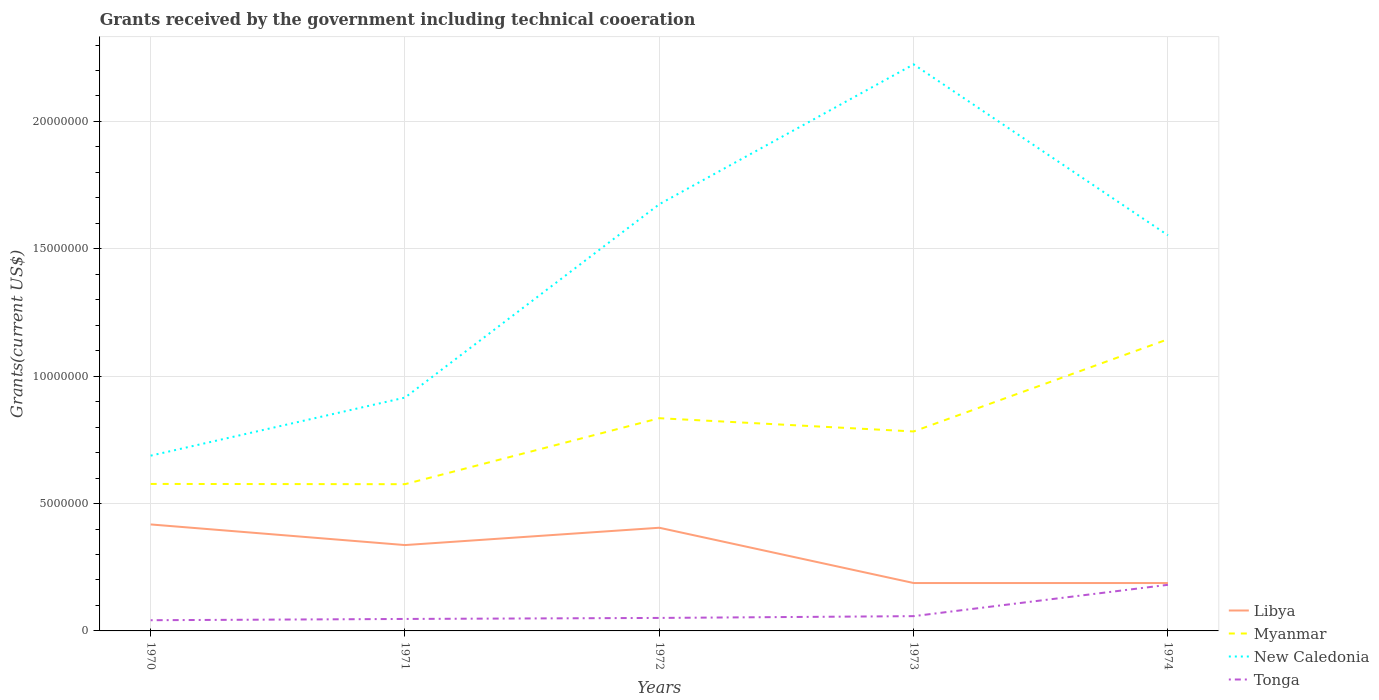How many different coloured lines are there?
Make the answer very short. 4. Across all years, what is the maximum total grants received by the government in Tonga?
Offer a very short reply. 4.20e+05. What is the total total grants received by the government in Myanmar in the graph?
Offer a terse response. -2.58e+06. What is the difference between the highest and the second highest total grants received by the government in Myanmar?
Give a very brief answer. 5.69e+06. Is the total grants received by the government in New Caledonia strictly greater than the total grants received by the government in Libya over the years?
Your answer should be very brief. No. How many lines are there?
Make the answer very short. 4. What is the difference between two consecutive major ticks on the Y-axis?
Offer a terse response. 5.00e+06. Does the graph contain any zero values?
Make the answer very short. No. Does the graph contain grids?
Ensure brevity in your answer.  Yes. Where does the legend appear in the graph?
Ensure brevity in your answer.  Bottom right. How many legend labels are there?
Provide a succinct answer. 4. How are the legend labels stacked?
Give a very brief answer. Vertical. What is the title of the graph?
Your response must be concise. Grants received by the government including technical cooeration. What is the label or title of the Y-axis?
Keep it short and to the point. Grants(current US$). What is the Grants(current US$) of Libya in 1970?
Keep it short and to the point. 4.18e+06. What is the Grants(current US$) in Myanmar in 1970?
Offer a terse response. 5.77e+06. What is the Grants(current US$) of New Caledonia in 1970?
Keep it short and to the point. 6.88e+06. What is the Grants(current US$) of Libya in 1971?
Give a very brief answer. 3.37e+06. What is the Grants(current US$) in Myanmar in 1971?
Ensure brevity in your answer.  5.76e+06. What is the Grants(current US$) in New Caledonia in 1971?
Keep it short and to the point. 9.16e+06. What is the Grants(current US$) of Libya in 1972?
Give a very brief answer. 4.05e+06. What is the Grants(current US$) of Myanmar in 1972?
Ensure brevity in your answer.  8.35e+06. What is the Grants(current US$) in New Caledonia in 1972?
Make the answer very short. 1.68e+07. What is the Grants(current US$) in Tonga in 1972?
Your answer should be compact. 5.10e+05. What is the Grants(current US$) of Libya in 1973?
Keep it short and to the point. 1.88e+06. What is the Grants(current US$) of Myanmar in 1973?
Your answer should be compact. 7.83e+06. What is the Grants(current US$) of New Caledonia in 1973?
Provide a succinct answer. 2.22e+07. What is the Grants(current US$) of Tonga in 1973?
Your answer should be very brief. 5.80e+05. What is the Grants(current US$) in Libya in 1974?
Your answer should be very brief. 1.88e+06. What is the Grants(current US$) of Myanmar in 1974?
Offer a very short reply. 1.14e+07. What is the Grants(current US$) of New Caledonia in 1974?
Keep it short and to the point. 1.55e+07. What is the Grants(current US$) of Tonga in 1974?
Ensure brevity in your answer.  1.81e+06. Across all years, what is the maximum Grants(current US$) in Libya?
Your response must be concise. 4.18e+06. Across all years, what is the maximum Grants(current US$) in Myanmar?
Keep it short and to the point. 1.14e+07. Across all years, what is the maximum Grants(current US$) in New Caledonia?
Make the answer very short. 2.22e+07. Across all years, what is the maximum Grants(current US$) in Tonga?
Your answer should be compact. 1.81e+06. Across all years, what is the minimum Grants(current US$) of Libya?
Make the answer very short. 1.88e+06. Across all years, what is the minimum Grants(current US$) in Myanmar?
Your answer should be very brief. 5.76e+06. Across all years, what is the minimum Grants(current US$) of New Caledonia?
Ensure brevity in your answer.  6.88e+06. Across all years, what is the minimum Grants(current US$) of Tonga?
Offer a terse response. 4.20e+05. What is the total Grants(current US$) in Libya in the graph?
Make the answer very short. 1.54e+07. What is the total Grants(current US$) in Myanmar in the graph?
Give a very brief answer. 3.92e+07. What is the total Grants(current US$) of New Caledonia in the graph?
Keep it short and to the point. 7.06e+07. What is the total Grants(current US$) in Tonga in the graph?
Your answer should be compact. 3.79e+06. What is the difference between the Grants(current US$) of Libya in 1970 and that in 1971?
Ensure brevity in your answer.  8.10e+05. What is the difference between the Grants(current US$) of New Caledonia in 1970 and that in 1971?
Give a very brief answer. -2.28e+06. What is the difference between the Grants(current US$) in Myanmar in 1970 and that in 1972?
Make the answer very short. -2.58e+06. What is the difference between the Grants(current US$) in New Caledonia in 1970 and that in 1972?
Your answer should be very brief. -9.87e+06. What is the difference between the Grants(current US$) of Libya in 1970 and that in 1973?
Offer a very short reply. 2.30e+06. What is the difference between the Grants(current US$) of Myanmar in 1970 and that in 1973?
Provide a short and direct response. -2.06e+06. What is the difference between the Grants(current US$) of New Caledonia in 1970 and that in 1973?
Ensure brevity in your answer.  -1.54e+07. What is the difference between the Grants(current US$) in Tonga in 1970 and that in 1973?
Keep it short and to the point. -1.60e+05. What is the difference between the Grants(current US$) in Libya in 1970 and that in 1974?
Give a very brief answer. 2.30e+06. What is the difference between the Grants(current US$) in Myanmar in 1970 and that in 1974?
Give a very brief answer. -5.68e+06. What is the difference between the Grants(current US$) in New Caledonia in 1970 and that in 1974?
Provide a succinct answer. -8.65e+06. What is the difference between the Grants(current US$) of Tonga in 1970 and that in 1974?
Make the answer very short. -1.39e+06. What is the difference between the Grants(current US$) of Libya in 1971 and that in 1972?
Provide a short and direct response. -6.80e+05. What is the difference between the Grants(current US$) of Myanmar in 1971 and that in 1972?
Your answer should be very brief. -2.59e+06. What is the difference between the Grants(current US$) in New Caledonia in 1971 and that in 1972?
Provide a short and direct response. -7.59e+06. What is the difference between the Grants(current US$) in Tonga in 1971 and that in 1972?
Keep it short and to the point. -4.00e+04. What is the difference between the Grants(current US$) of Libya in 1971 and that in 1973?
Make the answer very short. 1.49e+06. What is the difference between the Grants(current US$) of Myanmar in 1971 and that in 1973?
Your answer should be compact. -2.07e+06. What is the difference between the Grants(current US$) in New Caledonia in 1971 and that in 1973?
Make the answer very short. -1.31e+07. What is the difference between the Grants(current US$) of Tonga in 1971 and that in 1973?
Provide a succinct answer. -1.10e+05. What is the difference between the Grants(current US$) in Libya in 1971 and that in 1974?
Offer a terse response. 1.49e+06. What is the difference between the Grants(current US$) in Myanmar in 1971 and that in 1974?
Ensure brevity in your answer.  -5.69e+06. What is the difference between the Grants(current US$) of New Caledonia in 1971 and that in 1974?
Ensure brevity in your answer.  -6.37e+06. What is the difference between the Grants(current US$) in Tonga in 1971 and that in 1974?
Offer a very short reply. -1.34e+06. What is the difference between the Grants(current US$) of Libya in 1972 and that in 1973?
Keep it short and to the point. 2.17e+06. What is the difference between the Grants(current US$) in Myanmar in 1972 and that in 1973?
Offer a very short reply. 5.20e+05. What is the difference between the Grants(current US$) in New Caledonia in 1972 and that in 1973?
Provide a succinct answer. -5.49e+06. What is the difference between the Grants(current US$) in Tonga in 1972 and that in 1973?
Keep it short and to the point. -7.00e+04. What is the difference between the Grants(current US$) in Libya in 1972 and that in 1974?
Your answer should be very brief. 2.17e+06. What is the difference between the Grants(current US$) of Myanmar in 1972 and that in 1974?
Keep it short and to the point. -3.10e+06. What is the difference between the Grants(current US$) of New Caledonia in 1972 and that in 1974?
Your response must be concise. 1.22e+06. What is the difference between the Grants(current US$) of Tonga in 1972 and that in 1974?
Offer a very short reply. -1.30e+06. What is the difference between the Grants(current US$) in Myanmar in 1973 and that in 1974?
Your answer should be very brief. -3.62e+06. What is the difference between the Grants(current US$) of New Caledonia in 1973 and that in 1974?
Your response must be concise. 6.71e+06. What is the difference between the Grants(current US$) of Tonga in 1973 and that in 1974?
Provide a short and direct response. -1.23e+06. What is the difference between the Grants(current US$) of Libya in 1970 and the Grants(current US$) of Myanmar in 1971?
Your response must be concise. -1.58e+06. What is the difference between the Grants(current US$) of Libya in 1970 and the Grants(current US$) of New Caledonia in 1971?
Keep it short and to the point. -4.98e+06. What is the difference between the Grants(current US$) in Libya in 1970 and the Grants(current US$) in Tonga in 1971?
Give a very brief answer. 3.71e+06. What is the difference between the Grants(current US$) in Myanmar in 1970 and the Grants(current US$) in New Caledonia in 1971?
Your answer should be very brief. -3.39e+06. What is the difference between the Grants(current US$) in Myanmar in 1970 and the Grants(current US$) in Tonga in 1971?
Offer a very short reply. 5.30e+06. What is the difference between the Grants(current US$) of New Caledonia in 1970 and the Grants(current US$) of Tonga in 1971?
Make the answer very short. 6.41e+06. What is the difference between the Grants(current US$) of Libya in 1970 and the Grants(current US$) of Myanmar in 1972?
Give a very brief answer. -4.17e+06. What is the difference between the Grants(current US$) in Libya in 1970 and the Grants(current US$) in New Caledonia in 1972?
Your response must be concise. -1.26e+07. What is the difference between the Grants(current US$) of Libya in 1970 and the Grants(current US$) of Tonga in 1972?
Offer a very short reply. 3.67e+06. What is the difference between the Grants(current US$) of Myanmar in 1970 and the Grants(current US$) of New Caledonia in 1972?
Provide a short and direct response. -1.10e+07. What is the difference between the Grants(current US$) in Myanmar in 1970 and the Grants(current US$) in Tonga in 1972?
Your answer should be very brief. 5.26e+06. What is the difference between the Grants(current US$) of New Caledonia in 1970 and the Grants(current US$) of Tonga in 1972?
Provide a succinct answer. 6.37e+06. What is the difference between the Grants(current US$) in Libya in 1970 and the Grants(current US$) in Myanmar in 1973?
Keep it short and to the point. -3.65e+06. What is the difference between the Grants(current US$) of Libya in 1970 and the Grants(current US$) of New Caledonia in 1973?
Your answer should be compact. -1.81e+07. What is the difference between the Grants(current US$) in Libya in 1970 and the Grants(current US$) in Tonga in 1973?
Make the answer very short. 3.60e+06. What is the difference between the Grants(current US$) in Myanmar in 1970 and the Grants(current US$) in New Caledonia in 1973?
Your response must be concise. -1.65e+07. What is the difference between the Grants(current US$) of Myanmar in 1970 and the Grants(current US$) of Tonga in 1973?
Keep it short and to the point. 5.19e+06. What is the difference between the Grants(current US$) in New Caledonia in 1970 and the Grants(current US$) in Tonga in 1973?
Provide a succinct answer. 6.30e+06. What is the difference between the Grants(current US$) in Libya in 1970 and the Grants(current US$) in Myanmar in 1974?
Provide a succinct answer. -7.27e+06. What is the difference between the Grants(current US$) in Libya in 1970 and the Grants(current US$) in New Caledonia in 1974?
Your answer should be compact. -1.14e+07. What is the difference between the Grants(current US$) of Libya in 1970 and the Grants(current US$) of Tonga in 1974?
Provide a short and direct response. 2.37e+06. What is the difference between the Grants(current US$) in Myanmar in 1970 and the Grants(current US$) in New Caledonia in 1974?
Offer a terse response. -9.76e+06. What is the difference between the Grants(current US$) in Myanmar in 1970 and the Grants(current US$) in Tonga in 1974?
Ensure brevity in your answer.  3.96e+06. What is the difference between the Grants(current US$) in New Caledonia in 1970 and the Grants(current US$) in Tonga in 1974?
Provide a short and direct response. 5.07e+06. What is the difference between the Grants(current US$) of Libya in 1971 and the Grants(current US$) of Myanmar in 1972?
Make the answer very short. -4.98e+06. What is the difference between the Grants(current US$) of Libya in 1971 and the Grants(current US$) of New Caledonia in 1972?
Keep it short and to the point. -1.34e+07. What is the difference between the Grants(current US$) of Libya in 1971 and the Grants(current US$) of Tonga in 1972?
Offer a very short reply. 2.86e+06. What is the difference between the Grants(current US$) of Myanmar in 1971 and the Grants(current US$) of New Caledonia in 1972?
Give a very brief answer. -1.10e+07. What is the difference between the Grants(current US$) in Myanmar in 1971 and the Grants(current US$) in Tonga in 1972?
Offer a very short reply. 5.25e+06. What is the difference between the Grants(current US$) of New Caledonia in 1971 and the Grants(current US$) of Tonga in 1972?
Provide a short and direct response. 8.65e+06. What is the difference between the Grants(current US$) of Libya in 1971 and the Grants(current US$) of Myanmar in 1973?
Provide a short and direct response. -4.46e+06. What is the difference between the Grants(current US$) of Libya in 1971 and the Grants(current US$) of New Caledonia in 1973?
Your answer should be very brief. -1.89e+07. What is the difference between the Grants(current US$) in Libya in 1971 and the Grants(current US$) in Tonga in 1973?
Ensure brevity in your answer.  2.79e+06. What is the difference between the Grants(current US$) in Myanmar in 1971 and the Grants(current US$) in New Caledonia in 1973?
Offer a terse response. -1.65e+07. What is the difference between the Grants(current US$) in Myanmar in 1971 and the Grants(current US$) in Tonga in 1973?
Offer a terse response. 5.18e+06. What is the difference between the Grants(current US$) of New Caledonia in 1971 and the Grants(current US$) of Tonga in 1973?
Provide a succinct answer. 8.58e+06. What is the difference between the Grants(current US$) in Libya in 1971 and the Grants(current US$) in Myanmar in 1974?
Keep it short and to the point. -8.08e+06. What is the difference between the Grants(current US$) in Libya in 1971 and the Grants(current US$) in New Caledonia in 1974?
Offer a terse response. -1.22e+07. What is the difference between the Grants(current US$) in Libya in 1971 and the Grants(current US$) in Tonga in 1974?
Provide a succinct answer. 1.56e+06. What is the difference between the Grants(current US$) of Myanmar in 1971 and the Grants(current US$) of New Caledonia in 1974?
Offer a very short reply. -9.77e+06. What is the difference between the Grants(current US$) in Myanmar in 1971 and the Grants(current US$) in Tonga in 1974?
Provide a short and direct response. 3.95e+06. What is the difference between the Grants(current US$) of New Caledonia in 1971 and the Grants(current US$) of Tonga in 1974?
Keep it short and to the point. 7.35e+06. What is the difference between the Grants(current US$) in Libya in 1972 and the Grants(current US$) in Myanmar in 1973?
Provide a short and direct response. -3.78e+06. What is the difference between the Grants(current US$) of Libya in 1972 and the Grants(current US$) of New Caledonia in 1973?
Keep it short and to the point. -1.82e+07. What is the difference between the Grants(current US$) of Libya in 1972 and the Grants(current US$) of Tonga in 1973?
Make the answer very short. 3.47e+06. What is the difference between the Grants(current US$) of Myanmar in 1972 and the Grants(current US$) of New Caledonia in 1973?
Ensure brevity in your answer.  -1.39e+07. What is the difference between the Grants(current US$) in Myanmar in 1972 and the Grants(current US$) in Tonga in 1973?
Make the answer very short. 7.77e+06. What is the difference between the Grants(current US$) in New Caledonia in 1972 and the Grants(current US$) in Tonga in 1973?
Provide a succinct answer. 1.62e+07. What is the difference between the Grants(current US$) in Libya in 1972 and the Grants(current US$) in Myanmar in 1974?
Provide a short and direct response. -7.40e+06. What is the difference between the Grants(current US$) of Libya in 1972 and the Grants(current US$) of New Caledonia in 1974?
Provide a short and direct response. -1.15e+07. What is the difference between the Grants(current US$) in Libya in 1972 and the Grants(current US$) in Tonga in 1974?
Your answer should be very brief. 2.24e+06. What is the difference between the Grants(current US$) in Myanmar in 1972 and the Grants(current US$) in New Caledonia in 1974?
Offer a very short reply. -7.18e+06. What is the difference between the Grants(current US$) of Myanmar in 1972 and the Grants(current US$) of Tonga in 1974?
Give a very brief answer. 6.54e+06. What is the difference between the Grants(current US$) of New Caledonia in 1972 and the Grants(current US$) of Tonga in 1974?
Provide a succinct answer. 1.49e+07. What is the difference between the Grants(current US$) in Libya in 1973 and the Grants(current US$) in Myanmar in 1974?
Offer a very short reply. -9.57e+06. What is the difference between the Grants(current US$) in Libya in 1973 and the Grants(current US$) in New Caledonia in 1974?
Offer a terse response. -1.36e+07. What is the difference between the Grants(current US$) in Myanmar in 1973 and the Grants(current US$) in New Caledonia in 1974?
Provide a succinct answer. -7.70e+06. What is the difference between the Grants(current US$) in Myanmar in 1973 and the Grants(current US$) in Tonga in 1974?
Give a very brief answer. 6.02e+06. What is the difference between the Grants(current US$) of New Caledonia in 1973 and the Grants(current US$) of Tonga in 1974?
Offer a terse response. 2.04e+07. What is the average Grants(current US$) in Libya per year?
Ensure brevity in your answer.  3.07e+06. What is the average Grants(current US$) of Myanmar per year?
Give a very brief answer. 7.83e+06. What is the average Grants(current US$) in New Caledonia per year?
Offer a terse response. 1.41e+07. What is the average Grants(current US$) of Tonga per year?
Give a very brief answer. 7.58e+05. In the year 1970, what is the difference between the Grants(current US$) of Libya and Grants(current US$) of Myanmar?
Give a very brief answer. -1.59e+06. In the year 1970, what is the difference between the Grants(current US$) of Libya and Grants(current US$) of New Caledonia?
Provide a succinct answer. -2.70e+06. In the year 1970, what is the difference between the Grants(current US$) in Libya and Grants(current US$) in Tonga?
Give a very brief answer. 3.76e+06. In the year 1970, what is the difference between the Grants(current US$) of Myanmar and Grants(current US$) of New Caledonia?
Make the answer very short. -1.11e+06. In the year 1970, what is the difference between the Grants(current US$) in Myanmar and Grants(current US$) in Tonga?
Your answer should be very brief. 5.35e+06. In the year 1970, what is the difference between the Grants(current US$) in New Caledonia and Grants(current US$) in Tonga?
Give a very brief answer. 6.46e+06. In the year 1971, what is the difference between the Grants(current US$) of Libya and Grants(current US$) of Myanmar?
Offer a very short reply. -2.39e+06. In the year 1971, what is the difference between the Grants(current US$) in Libya and Grants(current US$) in New Caledonia?
Keep it short and to the point. -5.79e+06. In the year 1971, what is the difference between the Grants(current US$) in Libya and Grants(current US$) in Tonga?
Offer a very short reply. 2.90e+06. In the year 1971, what is the difference between the Grants(current US$) of Myanmar and Grants(current US$) of New Caledonia?
Keep it short and to the point. -3.40e+06. In the year 1971, what is the difference between the Grants(current US$) in Myanmar and Grants(current US$) in Tonga?
Offer a very short reply. 5.29e+06. In the year 1971, what is the difference between the Grants(current US$) of New Caledonia and Grants(current US$) of Tonga?
Offer a terse response. 8.69e+06. In the year 1972, what is the difference between the Grants(current US$) of Libya and Grants(current US$) of Myanmar?
Provide a succinct answer. -4.30e+06. In the year 1972, what is the difference between the Grants(current US$) of Libya and Grants(current US$) of New Caledonia?
Offer a very short reply. -1.27e+07. In the year 1972, what is the difference between the Grants(current US$) of Libya and Grants(current US$) of Tonga?
Give a very brief answer. 3.54e+06. In the year 1972, what is the difference between the Grants(current US$) of Myanmar and Grants(current US$) of New Caledonia?
Your response must be concise. -8.40e+06. In the year 1972, what is the difference between the Grants(current US$) of Myanmar and Grants(current US$) of Tonga?
Your response must be concise. 7.84e+06. In the year 1972, what is the difference between the Grants(current US$) of New Caledonia and Grants(current US$) of Tonga?
Provide a short and direct response. 1.62e+07. In the year 1973, what is the difference between the Grants(current US$) in Libya and Grants(current US$) in Myanmar?
Offer a terse response. -5.95e+06. In the year 1973, what is the difference between the Grants(current US$) in Libya and Grants(current US$) in New Caledonia?
Provide a short and direct response. -2.04e+07. In the year 1973, what is the difference between the Grants(current US$) in Libya and Grants(current US$) in Tonga?
Make the answer very short. 1.30e+06. In the year 1973, what is the difference between the Grants(current US$) of Myanmar and Grants(current US$) of New Caledonia?
Your answer should be very brief. -1.44e+07. In the year 1973, what is the difference between the Grants(current US$) of Myanmar and Grants(current US$) of Tonga?
Offer a very short reply. 7.25e+06. In the year 1973, what is the difference between the Grants(current US$) in New Caledonia and Grants(current US$) in Tonga?
Provide a short and direct response. 2.17e+07. In the year 1974, what is the difference between the Grants(current US$) in Libya and Grants(current US$) in Myanmar?
Give a very brief answer. -9.57e+06. In the year 1974, what is the difference between the Grants(current US$) in Libya and Grants(current US$) in New Caledonia?
Offer a terse response. -1.36e+07. In the year 1974, what is the difference between the Grants(current US$) of Myanmar and Grants(current US$) of New Caledonia?
Offer a very short reply. -4.08e+06. In the year 1974, what is the difference between the Grants(current US$) of Myanmar and Grants(current US$) of Tonga?
Offer a very short reply. 9.64e+06. In the year 1974, what is the difference between the Grants(current US$) in New Caledonia and Grants(current US$) in Tonga?
Your answer should be very brief. 1.37e+07. What is the ratio of the Grants(current US$) in Libya in 1970 to that in 1971?
Make the answer very short. 1.24. What is the ratio of the Grants(current US$) in Myanmar in 1970 to that in 1971?
Your answer should be very brief. 1. What is the ratio of the Grants(current US$) of New Caledonia in 1970 to that in 1971?
Give a very brief answer. 0.75. What is the ratio of the Grants(current US$) in Tonga in 1970 to that in 1971?
Give a very brief answer. 0.89. What is the ratio of the Grants(current US$) in Libya in 1970 to that in 1972?
Offer a terse response. 1.03. What is the ratio of the Grants(current US$) of Myanmar in 1970 to that in 1972?
Provide a short and direct response. 0.69. What is the ratio of the Grants(current US$) of New Caledonia in 1970 to that in 1972?
Make the answer very short. 0.41. What is the ratio of the Grants(current US$) in Tonga in 1970 to that in 1972?
Offer a very short reply. 0.82. What is the ratio of the Grants(current US$) of Libya in 1970 to that in 1973?
Make the answer very short. 2.22. What is the ratio of the Grants(current US$) of Myanmar in 1970 to that in 1973?
Offer a terse response. 0.74. What is the ratio of the Grants(current US$) in New Caledonia in 1970 to that in 1973?
Offer a terse response. 0.31. What is the ratio of the Grants(current US$) of Tonga in 1970 to that in 1973?
Offer a terse response. 0.72. What is the ratio of the Grants(current US$) in Libya in 1970 to that in 1974?
Give a very brief answer. 2.22. What is the ratio of the Grants(current US$) of Myanmar in 1970 to that in 1974?
Your answer should be very brief. 0.5. What is the ratio of the Grants(current US$) of New Caledonia in 1970 to that in 1974?
Your response must be concise. 0.44. What is the ratio of the Grants(current US$) in Tonga in 1970 to that in 1974?
Your answer should be compact. 0.23. What is the ratio of the Grants(current US$) of Libya in 1971 to that in 1972?
Give a very brief answer. 0.83. What is the ratio of the Grants(current US$) of Myanmar in 1971 to that in 1972?
Make the answer very short. 0.69. What is the ratio of the Grants(current US$) of New Caledonia in 1971 to that in 1972?
Keep it short and to the point. 0.55. What is the ratio of the Grants(current US$) in Tonga in 1971 to that in 1972?
Provide a succinct answer. 0.92. What is the ratio of the Grants(current US$) in Libya in 1971 to that in 1973?
Give a very brief answer. 1.79. What is the ratio of the Grants(current US$) in Myanmar in 1971 to that in 1973?
Your answer should be compact. 0.74. What is the ratio of the Grants(current US$) in New Caledonia in 1971 to that in 1973?
Make the answer very short. 0.41. What is the ratio of the Grants(current US$) in Tonga in 1971 to that in 1973?
Ensure brevity in your answer.  0.81. What is the ratio of the Grants(current US$) of Libya in 1971 to that in 1974?
Your answer should be very brief. 1.79. What is the ratio of the Grants(current US$) of Myanmar in 1971 to that in 1974?
Your answer should be compact. 0.5. What is the ratio of the Grants(current US$) in New Caledonia in 1971 to that in 1974?
Offer a terse response. 0.59. What is the ratio of the Grants(current US$) in Tonga in 1971 to that in 1974?
Your response must be concise. 0.26. What is the ratio of the Grants(current US$) of Libya in 1972 to that in 1973?
Your answer should be very brief. 2.15. What is the ratio of the Grants(current US$) of Myanmar in 1972 to that in 1973?
Your response must be concise. 1.07. What is the ratio of the Grants(current US$) in New Caledonia in 1972 to that in 1973?
Make the answer very short. 0.75. What is the ratio of the Grants(current US$) of Tonga in 1972 to that in 1973?
Give a very brief answer. 0.88. What is the ratio of the Grants(current US$) of Libya in 1972 to that in 1974?
Make the answer very short. 2.15. What is the ratio of the Grants(current US$) of Myanmar in 1972 to that in 1974?
Give a very brief answer. 0.73. What is the ratio of the Grants(current US$) in New Caledonia in 1972 to that in 1974?
Provide a succinct answer. 1.08. What is the ratio of the Grants(current US$) of Tonga in 1972 to that in 1974?
Offer a very short reply. 0.28. What is the ratio of the Grants(current US$) in Myanmar in 1973 to that in 1974?
Your answer should be very brief. 0.68. What is the ratio of the Grants(current US$) of New Caledonia in 1973 to that in 1974?
Your answer should be compact. 1.43. What is the ratio of the Grants(current US$) in Tonga in 1973 to that in 1974?
Ensure brevity in your answer.  0.32. What is the difference between the highest and the second highest Grants(current US$) in Myanmar?
Offer a terse response. 3.10e+06. What is the difference between the highest and the second highest Grants(current US$) of New Caledonia?
Keep it short and to the point. 5.49e+06. What is the difference between the highest and the second highest Grants(current US$) of Tonga?
Make the answer very short. 1.23e+06. What is the difference between the highest and the lowest Grants(current US$) of Libya?
Offer a very short reply. 2.30e+06. What is the difference between the highest and the lowest Grants(current US$) of Myanmar?
Ensure brevity in your answer.  5.69e+06. What is the difference between the highest and the lowest Grants(current US$) in New Caledonia?
Ensure brevity in your answer.  1.54e+07. What is the difference between the highest and the lowest Grants(current US$) of Tonga?
Provide a succinct answer. 1.39e+06. 